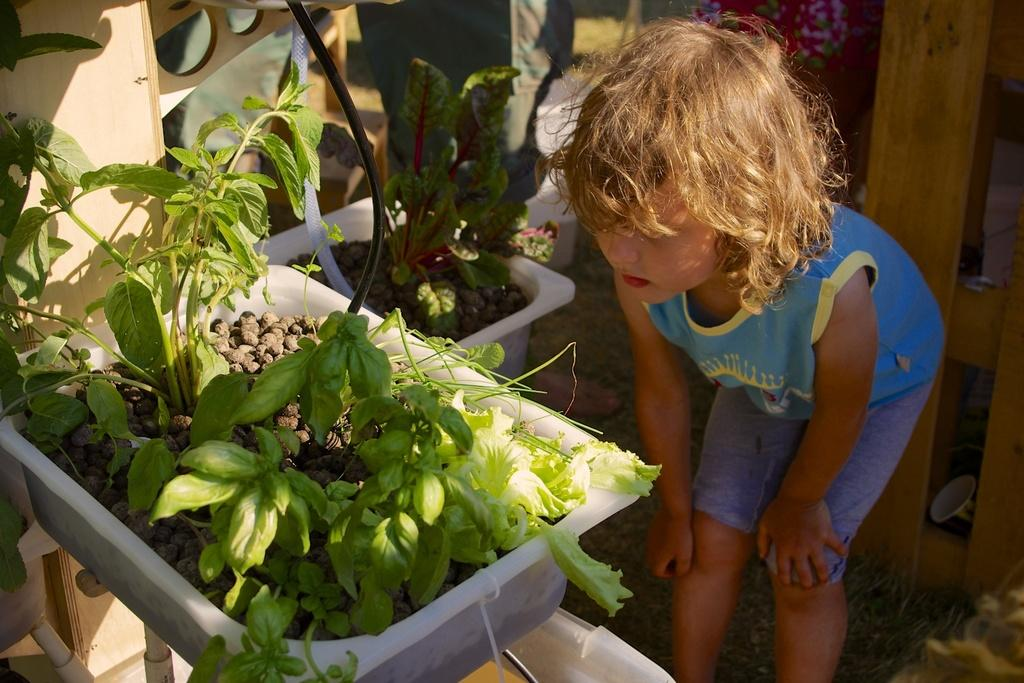What is the main subject of the image? The main subject of the image is a boy standing. What can be seen in the image besides the boy? There are green color plants in a tray in the image. What news is the boy reading in the image? There is no news or reading material visible in the image; the boy is simply standing. 